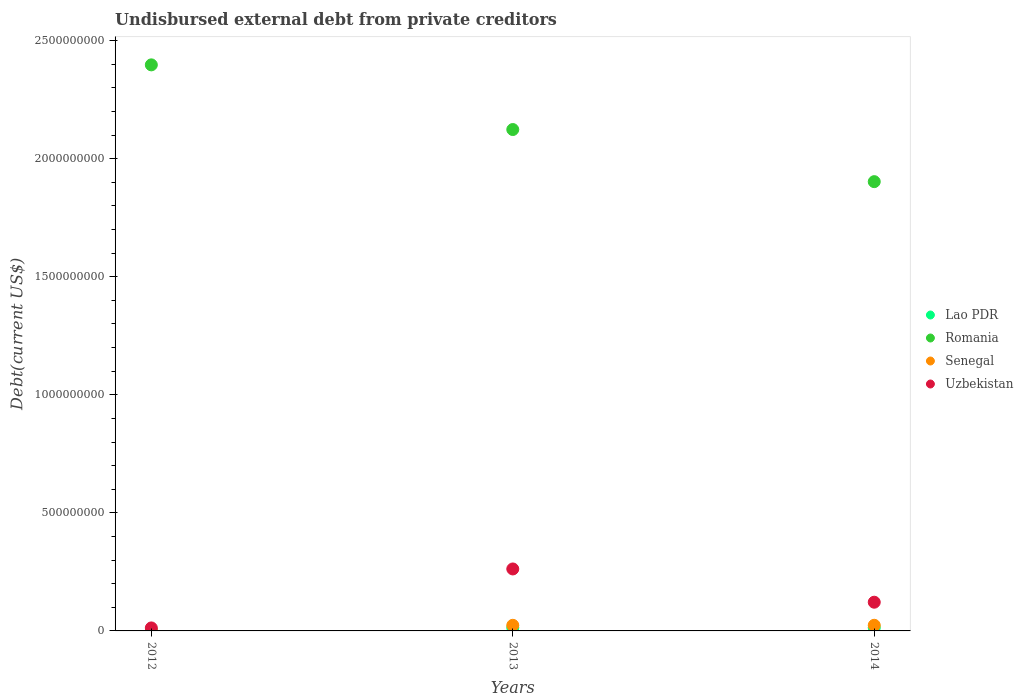What is the total debt in Senegal in 2014?
Keep it short and to the point. 2.39e+07. Across all years, what is the maximum total debt in Romania?
Your answer should be compact. 2.40e+09. Across all years, what is the minimum total debt in Romania?
Your answer should be very brief. 1.90e+09. In which year was the total debt in Uzbekistan minimum?
Give a very brief answer. 2012. What is the total total debt in Lao PDR in the graph?
Make the answer very short. 2.98e+07. What is the difference between the total debt in Uzbekistan in 2012 and that in 2014?
Your answer should be compact. -1.09e+08. What is the difference between the total debt in Senegal in 2013 and the total debt in Uzbekistan in 2014?
Keep it short and to the point. -9.78e+07. What is the average total debt in Senegal per year?
Keep it short and to the point. 1.63e+07. In the year 2014, what is the difference between the total debt in Senegal and total debt in Romania?
Ensure brevity in your answer.  -1.88e+09. In how many years, is the total debt in Uzbekistan greater than 1600000000 US$?
Offer a terse response. 0. What is the ratio of the total debt in Senegal in 2013 to that in 2014?
Offer a terse response. 0.99. Is the difference between the total debt in Senegal in 2012 and 2014 greater than the difference between the total debt in Romania in 2012 and 2014?
Your answer should be compact. No. What is the difference between the highest and the second highest total debt in Senegal?
Make the answer very short. 1.24e+05. What is the difference between the highest and the lowest total debt in Uzbekistan?
Keep it short and to the point. 2.50e+08. Does the total debt in Romania monotonically increase over the years?
Your answer should be compact. No. Is the total debt in Uzbekistan strictly less than the total debt in Romania over the years?
Keep it short and to the point. Yes. How many dotlines are there?
Provide a short and direct response. 4. Does the graph contain any zero values?
Make the answer very short. No. How are the legend labels stacked?
Keep it short and to the point. Vertical. What is the title of the graph?
Make the answer very short. Undisbursed external debt from private creditors. What is the label or title of the X-axis?
Keep it short and to the point. Years. What is the label or title of the Y-axis?
Ensure brevity in your answer.  Debt(current US$). What is the Debt(current US$) of Lao PDR in 2012?
Provide a succinct answer. 2.76e+06. What is the Debt(current US$) of Romania in 2012?
Provide a succinct answer. 2.40e+09. What is the Debt(current US$) in Senegal in 2012?
Offer a terse response. 1.28e+06. What is the Debt(current US$) of Uzbekistan in 2012?
Keep it short and to the point. 1.27e+07. What is the Debt(current US$) of Lao PDR in 2013?
Your response must be concise. 1.35e+07. What is the Debt(current US$) of Romania in 2013?
Provide a succinct answer. 2.12e+09. What is the Debt(current US$) in Senegal in 2013?
Your answer should be compact. 2.38e+07. What is the Debt(current US$) in Uzbekistan in 2013?
Ensure brevity in your answer.  2.62e+08. What is the Debt(current US$) in Lao PDR in 2014?
Your answer should be compact. 1.36e+07. What is the Debt(current US$) of Romania in 2014?
Provide a succinct answer. 1.90e+09. What is the Debt(current US$) in Senegal in 2014?
Your answer should be compact. 2.39e+07. What is the Debt(current US$) of Uzbekistan in 2014?
Give a very brief answer. 1.22e+08. Across all years, what is the maximum Debt(current US$) of Lao PDR?
Offer a terse response. 1.36e+07. Across all years, what is the maximum Debt(current US$) of Romania?
Ensure brevity in your answer.  2.40e+09. Across all years, what is the maximum Debt(current US$) in Senegal?
Offer a terse response. 2.39e+07. Across all years, what is the maximum Debt(current US$) in Uzbekistan?
Your answer should be very brief. 2.62e+08. Across all years, what is the minimum Debt(current US$) of Lao PDR?
Your response must be concise. 2.76e+06. Across all years, what is the minimum Debt(current US$) in Romania?
Provide a short and direct response. 1.90e+09. Across all years, what is the minimum Debt(current US$) of Senegal?
Provide a succinct answer. 1.28e+06. Across all years, what is the minimum Debt(current US$) of Uzbekistan?
Ensure brevity in your answer.  1.27e+07. What is the total Debt(current US$) in Lao PDR in the graph?
Your response must be concise. 2.98e+07. What is the total Debt(current US$) in Romania in the graph?
Ensure brevity in your answer.  6.42e+09. What is the total Debt(current US$) in Senegal in the graph?
Offer a very short reply. 4.90e+07. What is the total Debt(current US$) in Uzbekistan in the graph?
Offer a terse response. 3.97e+08. What is the difference between the Debt(current US$) in Lao PDR in 2012 and that in 2013?
Your answer should be compact. -1.07e+07. What is the difference between the Debt(current US$) in Romania in 2012 and that in 2013?
Make the answer very short. 2.74e+08. What is the difference between the Debt(current US$) of Senegal in 2012 and that in 2013?
Keep it short and to the point. -2.25e+07. What is the difference between the Debt(current US$) in Uzbekistan in 2012 and that in 2013?
Give a very brief answer. -2.50e+08. What is the difference between the Debt(current US$) of Lao PDR in 2012 and that in 2014?
Provide a succinct answer. -1.08e+07. What is the difference between the Debt(current US$) in Romania in 2012 and that in 2014?
Keep it short and to the point. 4.95e+08. What is the difference between the Debt(current US$) in Senegal in 2012 and that in 2014?
Provide a succinct answer. -2.26e+07. What is the difference between the Debt(current US$) in Uzbekistan in 2012 and that in 2014?
Your answer should be compact. -1.09e+08. What is the difference between the Debt(current US$) in Lao PDR in 2013 and that in 2014?
Keep it short and to the point. -1.26e+05. What is the difference between the Debt(current US$) of Romania in 2013 and that in 2014?
Your answer should be very brief. 2.21e+08. What is the difference between the Debt(current US$) of Senegal in 2013 and that in 2014?
Your answer should be very brief. -1.24e+05. What is the difference between the Debt(current US$) in Uzbekistan in 2013 and that in 2014?
Keep it short and to the point. 1.41e+08. What is the difference between the Debt(current US$) of Lao PDR in 2012 and the Debt(current US$) of Romania in 2013?
Make the answer very short. -2.12e+09. What is the difference between the Debt(current US$) in Lao PDR in 2012 and the Debt(current US$) in Senegal in 2013?
Offer a terse response. -2.10e+07. What is the difference between the Debt(current US$) in Lao PDR in 2012 and the Debt(current US$) in Uzbekistan in 2013?
Your answer should be very brief. -2.60e+08. What is the difference between the Debt(current US$) of Romania in 2012 and the Debt(current US$) of Senegal in 2013?
Ensure brevity in your answer.  2.37e+09. What is the difference between the Debt(current US$) of Romania in 2012 and the Debt(current US$) of Uzbekistan in 2013?
Provide a short and direct response. 2.13e+09. What is the difference between the Debt(current US$) in Senegal in 2012 and the Debt(current US$) in Uzbekistan in 2013?
Offer a terse response. -2.61e+08. What is the difference between the Debt(current US$) in Lao PDR in 2012 and the Debt(current US$) in Romania in 2014?
Provide a succinct answer. -1.90e+09. What is the difference between the Debt(current US$) in Lao PDR in 2012 and the Debt(current US$) in Senegal in 2014?
Make the answer very short. -2.12e+07. What is the difference between the Debt(current US$) of Lao PDR in 2012 and the Debt(current US$) of Uzbekistan in 2014?
Keep it short and to the point. -1.19e+08. What is the difference between the Debt(current US$) of Romania in 2012 and the Debt(current US$) of Senegal in 2014?
Your answer should be very brief. 2.37e+09. What is the difference between the Debt(current US$) in Romania in 2012 and the Debt(current US$) in Uzbekistan in 2014?
Your answer should be compact. 2.28e+09. What is the difference between the Debt(current US$) in Senegal in 2012 and the Debt(current US$) in Uzbekistan in 2014?
Make the answer very short. -1.20e+08. What is the difference between the Debt(current US$) of Lao PDR in 2013 and the Debt(current US$) of Romania in 2014?
Offer a very short reply. -1.89e+09. What is the difference between the Debt(current US$) of Lao PDR in 2013 and the Debt(current US$) of Senegal in 2014?
Ensure brevity in your answer.  -1.05e+07. What is the difference between the Debt(current US$) of Lao PDR in 2013 and the Debt(current US$) of Uzbekistan in 2014?
Provide a short and direct response. -1.08e+08. What is the difference between the Debt(current US$) of Romania in 2013 and the Debt(current US$) of Senegal in 2014?
Ensure brevity in your answer.  2.10e+09. What is the difference between the Debt(current US$) of Romania in 2013 and the Debt(current US$) of Uzbekistan in 2014?
Provide a succinct answer. 2.00e+09. What is the difference between the Debt(current US$) of Senegal in 2013 and the Debt(current US$) of Uzbekistan in 2014?
Keep it short and to the point. -9.78e+07. What is the average Debt(current US$) of Lao PDR per year?
Your response must be concise. 9.93e+06. What is the average Debt(current US$) in Romania per year?
Your answer should be compact. 2.14e+09. What is the average Debt(current US$) in Senegal per year?
Your answer should be compact. 1.63e+07. What is the average Debt(current US$) in Uzbekistan per year?
Ensure brevity in your answer.  1.32e+08. In the year 2012, what is the difference between the Debt(current US$) of Lao PDR and Debt(current US$) of Romania?
Ensure brevity in your answer.  -2.39e+09. In the year 2012, what is the difference between the Debt(current US$) of Lao PDR and Debt(current US$) of Senegal?
Give a very brief answer. 1.48e+06. In the year 2012, what is the difference between the Debt(current US$) of Lao PDR and Debt(current US$) of Uzbekistan?
Offer a very short reply. -9.94e+06. In the year 2012, what is the difference between the Debt(current US$) of Romania and Debt(current US$) of Senegal?
Provide a short and direct response. 2.40e+09. In the year 2012, what is the difference between the Debt(current US$) of Romania and Debt(current US$) of Uzbekistan?
Your answer should be compact. 2.38e+09. In the year 2012, what is the difference between the Debt(current US$) in Senegal and Debt(current US$) in Uzbekistan?
Make the answer very short. -1.14e+07. In the year 2013, what is the difference between the Debt(current US$) of Lao PDR and Debt(current US$) of Romania?
Your response must be concise. -2.11e+09. In the year 2013, what is the difference between the Debt(current US$) in Lao PDR and Debt(current US$) in Senegal?
Your response must be concise. -1.03e+07. In the year 2013, what is the difference between the Debt(current US$) in Lao PDR and Debt(current US$) in Uzbekistan?
Your response must be concise. -2.49e+08. In the year 2013, what is the difference between the Debt(current US$) of Romania and Debt(current US$) of Senegal?
Offer a very short reply. 2.10e+09. In the year 2013, what is the difference between the Debt(current US$) of Romania and Debt(current US$) of Uzbekistan?
Your answer should be compact. 1.86e+09. In the year 2013, what is the difference between the Debt(current US$) in Senegal and Debt(current US$) in Uzbekistan?
Offer a very short reply. -2.39e+08. In the year 2014, what is the difference between the Debt(current US$) of Lao PDR and Debt(current US$) of Romania?
Offer a very short reply. -1.89e+09. In the year 2014, what is the difference between the Debt(current US$) in Lao PDR and Debt(current US$) in Senegal?
Provide a short and direct response. -1.03e+07. In the year 2014, what is the difference between the Debt(current US$) in Lao PDR and Debt(current US$) in Uzbekistan?
Provide a succinct answer. -1.08e+08. In the year 2014, what is the difference between the Debt(current US$) in Romania and Debt(current US$) in Senegal?
Offer a very short reply. 1.88e+09. In the year 2014, what is the difference between the Debt(current US$) of Romania and Debt(current US$) of Uzbekistan?
Your answer should be compact. 1.78e+09. In the year 2014, what is the difference between the Debt(current US$) of Senegal and Debt(current US$) of Uzbekistan?
Provide a succinct answer. -9.77e+07. What is the ratio of the Debt(current US$) in Lao PDR in 2012 to that in 2013?
Provide a short and direct response. 0.21. What is the ratio of the Debt(current US$) of Romania in 2012 to that in 2013?
Your answer should be compact. 1.13. What is the ratio of the Debt(current US$) of Senegal in 2012 to that in 2013?
Offer a terse response. 0.05. What is the ratio of the Debt(current US$) in Uzbekistan in 2012 to that in 2013?
Provide a short and direct response. 0.05. What is the ratio of the Debt(current US$) in Lao PDR in 2012 to that in 2014?
Make the answer very short. 0.2. What is the ratio of the Debt(current US$) in Romania in 2012 to that in 2014?
Your response must be concise. 1.26. What is the ratio of the Debt(current US$) in Senegal in 2012 to that in 2014?
Your answer should be very brief. 0.05. What is the ratio of the Debt(current US$) of Uzbekistan in 2012 to that in 2014?
Offer a terse response. 0.1. What is the ratio of the Debt(current US$) of Lao PDR in 2013 to that in 2014?
Offer a very short reply. 0.99. What is the ratio of the Debt(current US$) in Romania in 2013 to that in 2014?
Offer a terse response. 1.12. What is the ratio of the Debt(current US$) of Senegal in 2013 to that in 2014?
Provide a short and direct response. 0.99. What is the ratio of the Debt(current US$) in Uzbekistan in 2013 to that in 2014?
Provide a succinct answer. 2.16. What is the difference between the highest and the second highest Debt(current US$) in Lao PDR?
Your response must be concise. 1.26e+05. What is the difference between the highest and the second highest Debt(current US$) in Romania?
Your answer should be compact. 2.74e+08. What is the difference between the highest and the second highest Debt(current US$) in Senegal?
Offer a terse response. 1.24e+05. What is the difference between the highest and the second highest Debt(current US$) in Uzbekistan?
Provide a short and direct response. 1.41e+08. What is the difference between the highest and the lowest Debt(current US$) of Lao PDR?
Keep it short and to the point. 1.08e+07. What is the difference between the highest and the lowest Debt(current US$) of Romania?
Provide a succinct answer. 4.95e+08. What is the difference between the highest and the lowest Debt(current US$) in Senegal?
Your answer should be compact. 2.26e+07. What is the difference between the highest and the lowest Debt(current US$) of Uzbekistan?
Make the answer very short. 2.50e+08. 